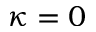Convert formula to latex. <formula><loc_0><loc_0><loc_500><loc_500>\kappa = 0</formula> 